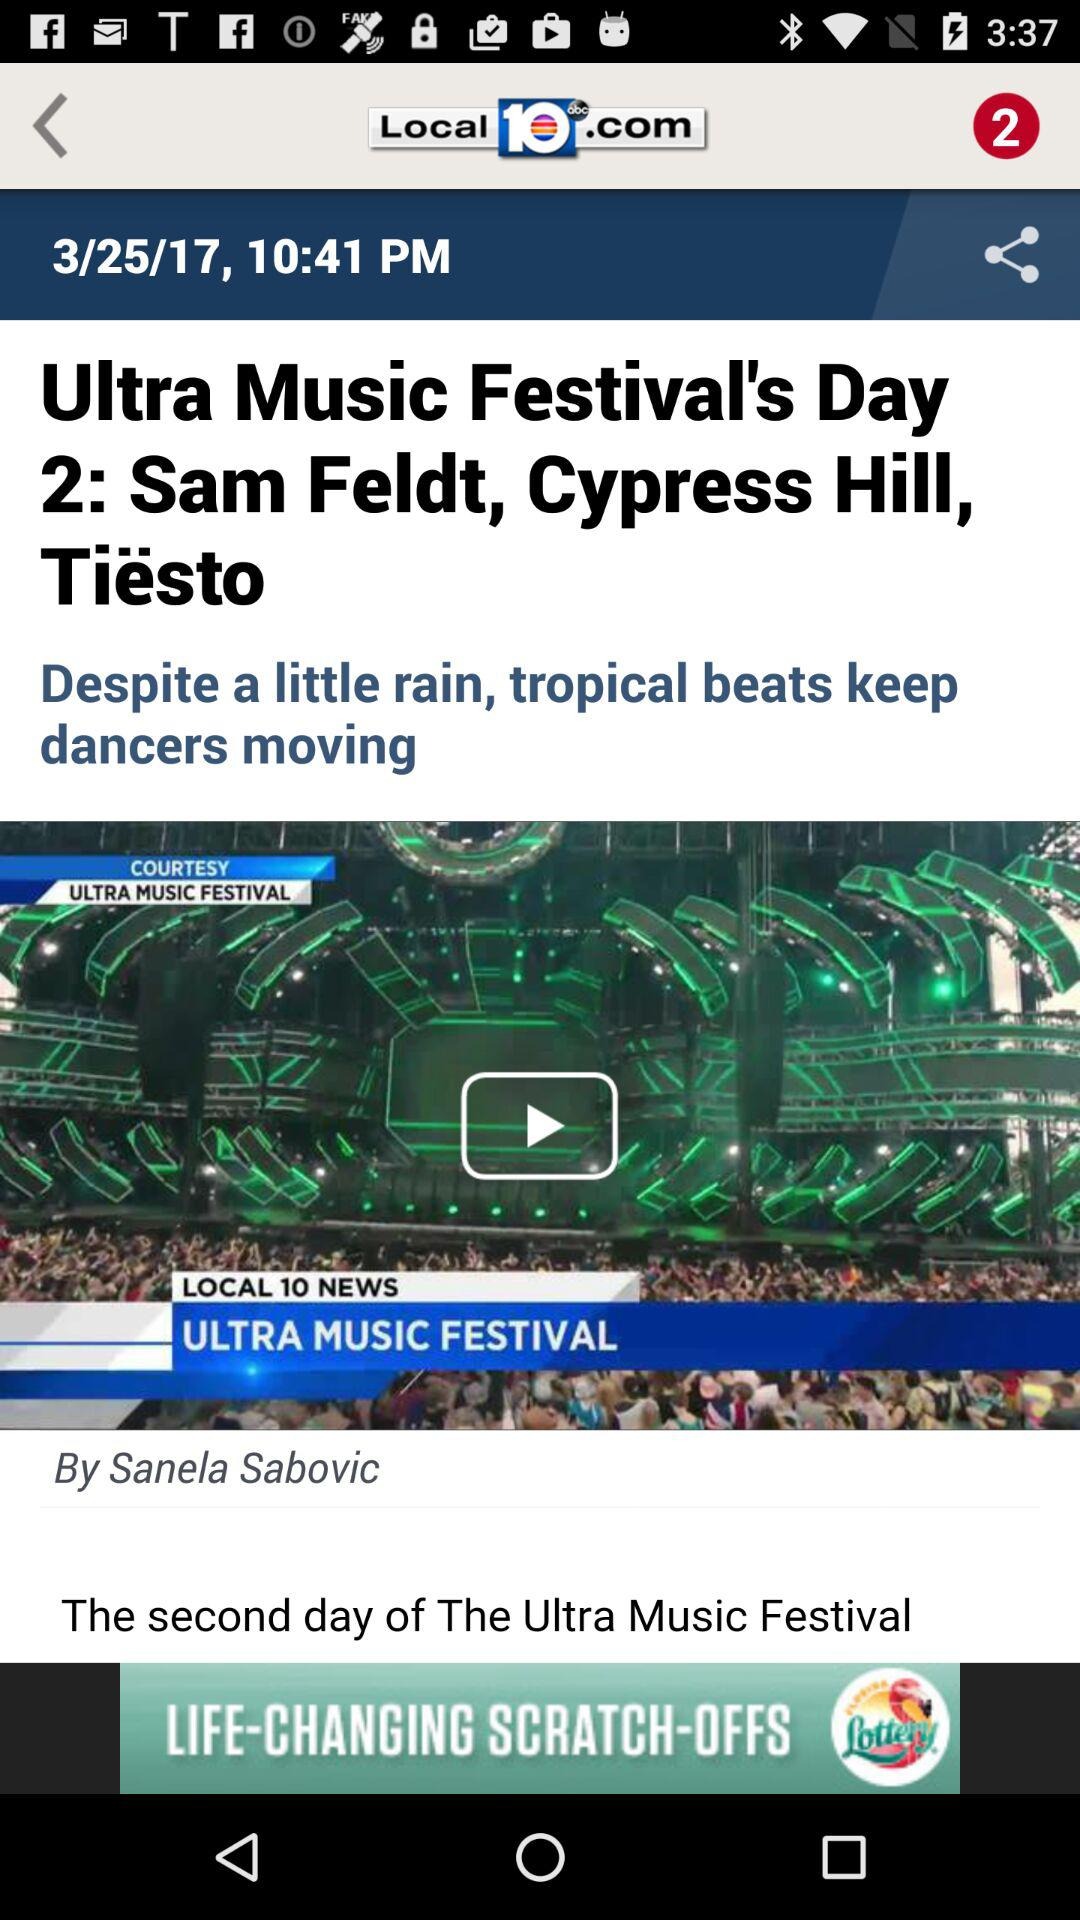What is the publication time of the content? The publication time of the content is 10:41 PM. 